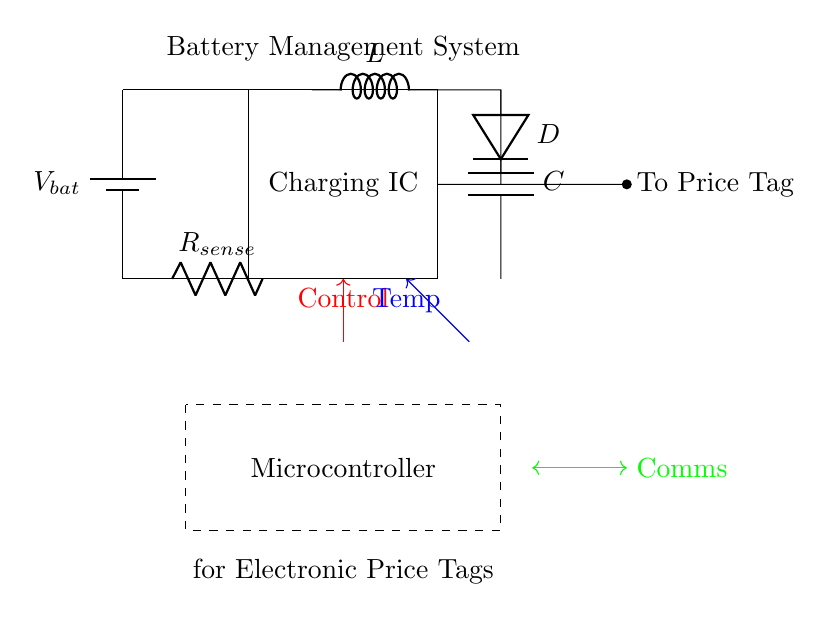What is the primary function of the charging IC? The charging IC is responsible for managing the charging process of the battery. It regulates voltage and current from the battery to ensure it is charged correctly.
Answer: Managing charging What component is used for current sensing in the circuit? The current sensing component is a resistor labeled as R_sense. Its purpose is to measure the current flowing through the circuit for monitoring and control.
Answer: R_sense How many major components are present in this circuit diagram? The major components include the battery, charging IC, microcontroller, resistor, inductor, capacitor, diode, and temperature sensor. Counting them gives a total of seven distinct parts.
Answer: Seven What role does the inductor play in this charging circuit? The inductor, labeled L, is used to store energy temporarily while regulating current flow. It helps in smoothing out the current during the charging process, providing better efficiency and stability.
Answer: Energy storage What is the purpose of the temperature sensor in this circuit? The temperature sensor monitors the temperature of the battery during charging to prevent overheating and ensure safe operation. This information can trigger control signals to adjust charging parameters.
Answer: Monitor battery temperature 